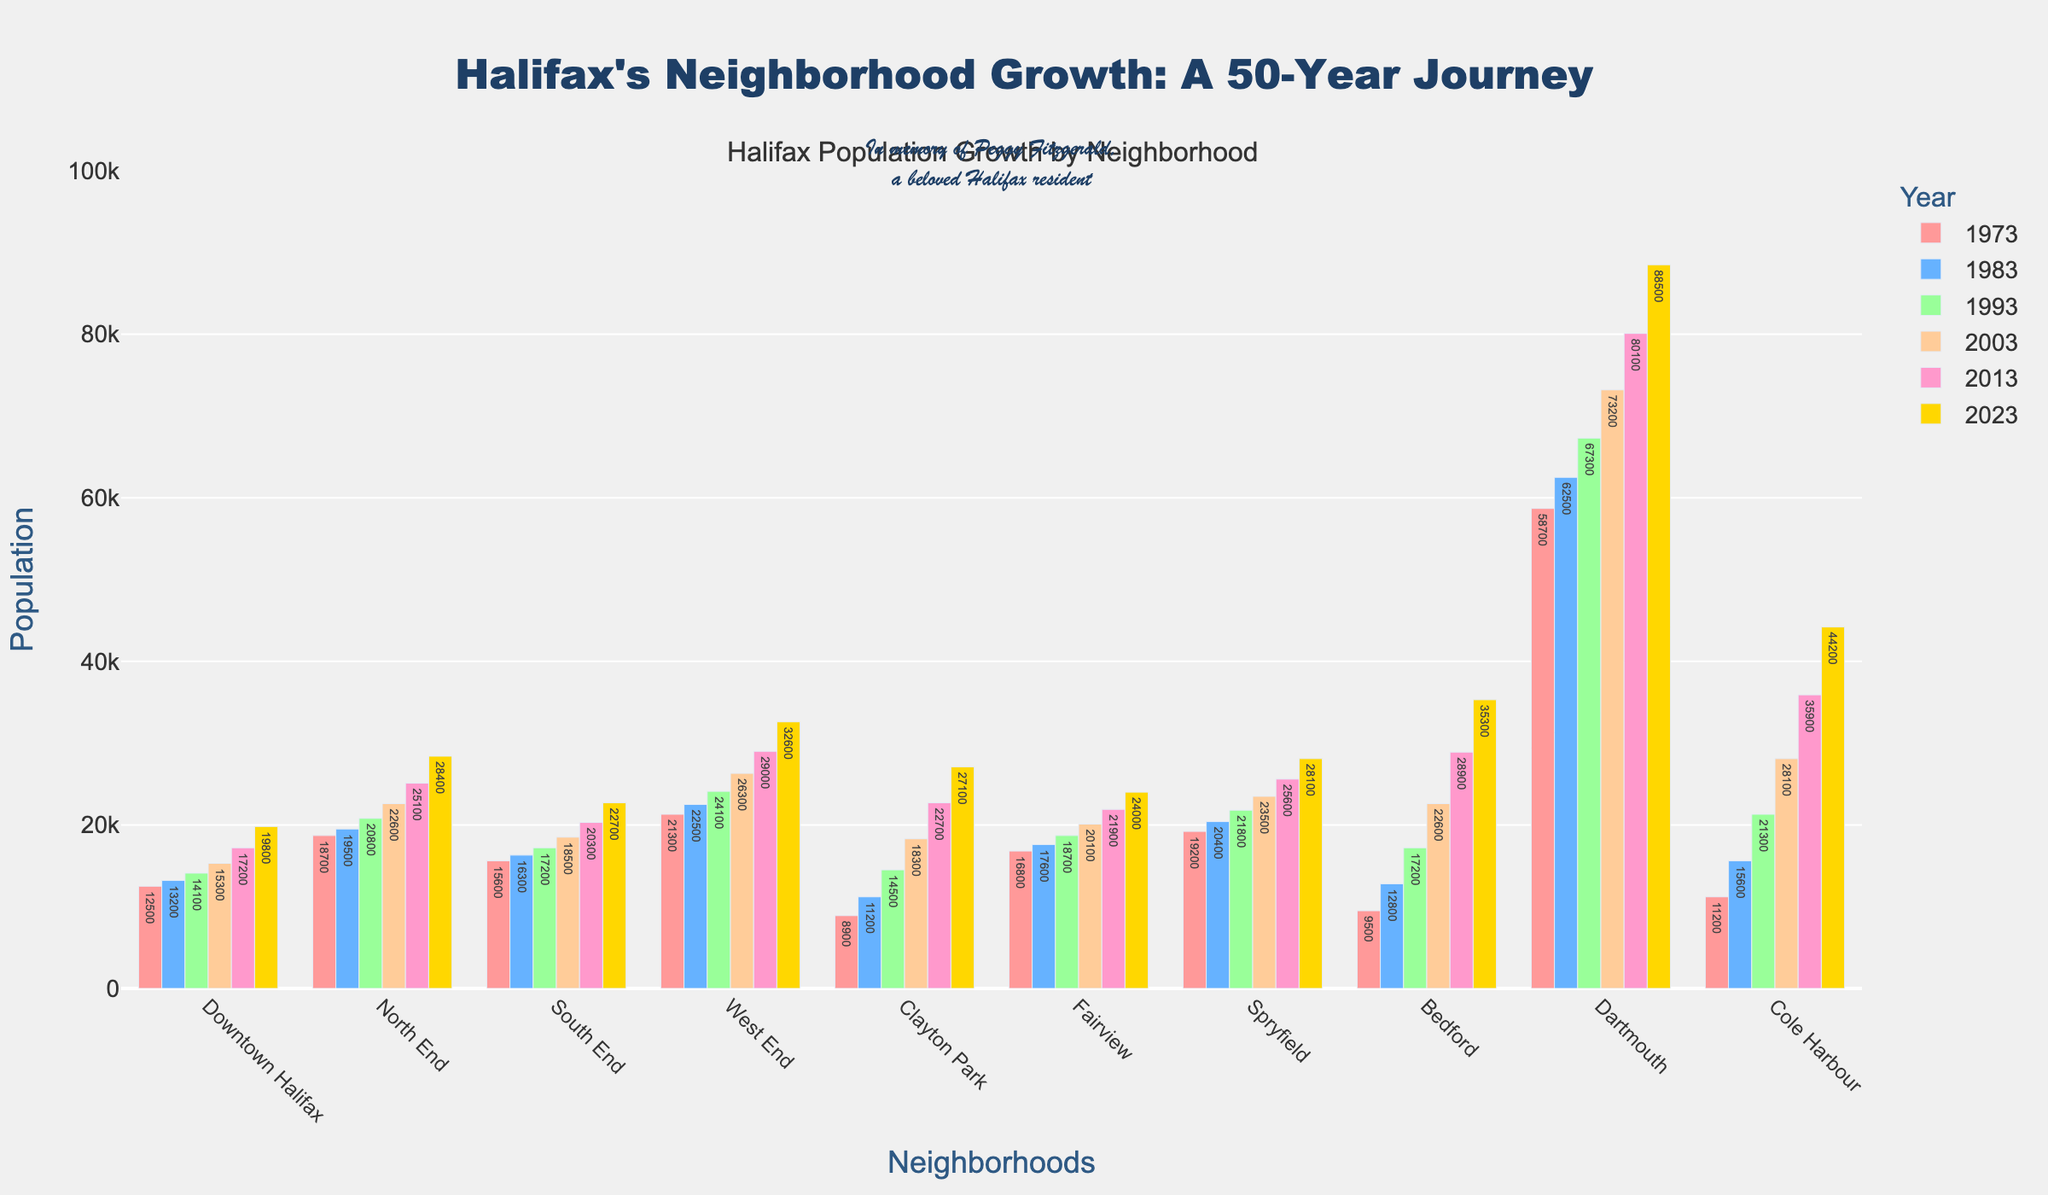What is the population growth in Downtown Halifax from 1973 to 2023? Start by noting the population in 1973, which is 12,500, and in 2023, which is 19,800. Then, subtract the population in 1973 from the population in 2023: 19,800 - 12,500.
Answer: 7,300 Which neighborhood had the highest population in 2023? Look at the bar heights for each neighborhood in 2023 and identify the tallest one. Dartmouth's bar is the tallest in 2023 with a population of 88,500.
Answer: Dartmouth How does the population trend in Bedford compare to that in Downtown Halifax over the 50 years? Note the populations for each decade in both Bedford and Downtown Halifax, observing the changes across the years. Bedford's population increased from 9,500 to 35,300, a more significant rise compared to Downtown Halifax's increase from 12,500 to 19,800.
Answer: Bedford had a faster growth Which two neighborhoods had the closest population in 2003? Check the populations for all neighborhoods in 2003, and identify which two have the smallest difference. Fairview and Spryfield both had close populations: 20,100 and 23,500 respectively.
Answer: Fairview and Spryfield What is the difference between the population of the South End and Fairview in 2013? Check the bars for the populations of South End and Fairview in 2013: South End has 20,300 and Fairview has 21,900. Then subtract the populations: 21,900 - 20,300.
Answer: 1,600 Which neighborhood had the smallest population growth from 1973 to 2023? Calculate the population growth for each neighborhood by subtracting the 1973 population from the 2023 population. Downtown Halifax grew by 7,300, which is the smallest increase.
Answer: Downtown Halifax In which decade did Dartmouth see the greatest increase in population? Compare the population increases for Dartmouth between each consecutive decade. The increase between 2003 (73,200) and 2013 (80,100) is the largest, which is 6,900.
Answer: 2003-2013 How many neighborhoods had a population above 30,000 in 2023? Look at the populations for all neighborhoods in 2023 and count how many have populations above 30,000. Downtown Halifax, North End, West End, Bedford, Dartmouth, Cole Harbour; 6 neighborhoods.
Answer: 6 What is the average population of all neighborhoods in 2013? Sum the populations of all neighborhoods in 2013 and divide by the number of neighborhoods (10). Calculation: (17,200 + 25,100 + 20,300 + 29,000 + 22,700 + 21,900 + 25,600 + 28,900 + 80,100 + 35,900) / 10 = 30,270.
Answer: 30,270 